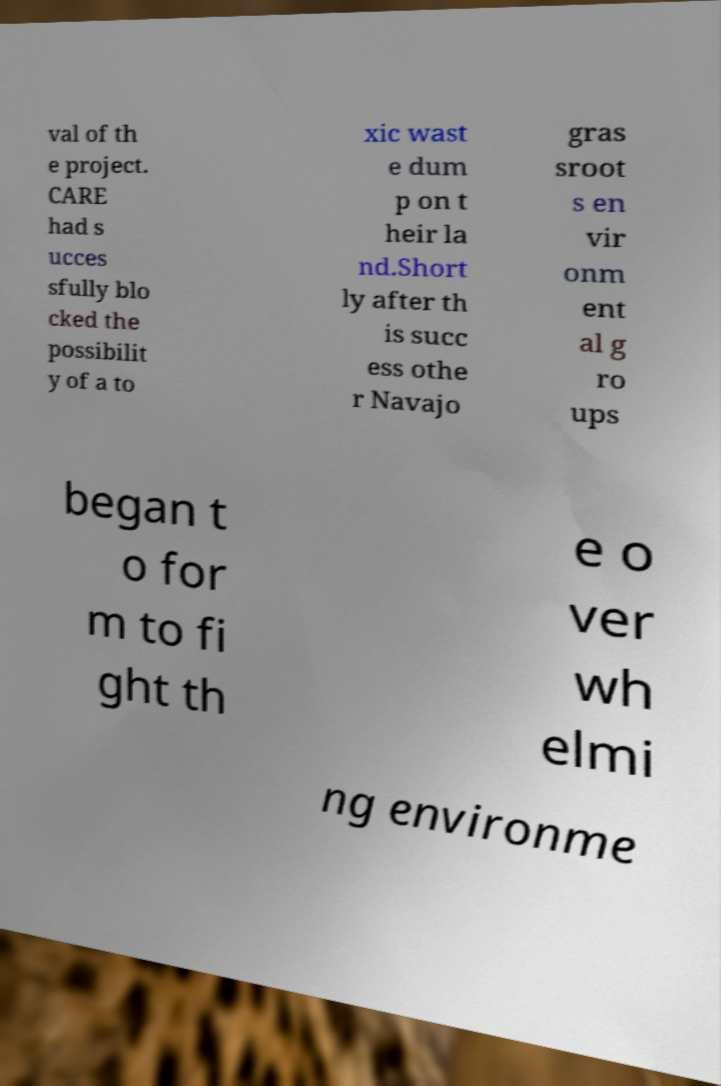I need the written content from this picture converted into text. Can you do that? val of th e project. CARE had s ucces sfully blo cked the possibilit y of a to xic wast e dum p on t heir la nd.Short ly after th is succ ess othe r Navajo gras sroot s en vir onm ent al g ro ups began t o for m to fi ght th e o ver wh elmi ng environme 